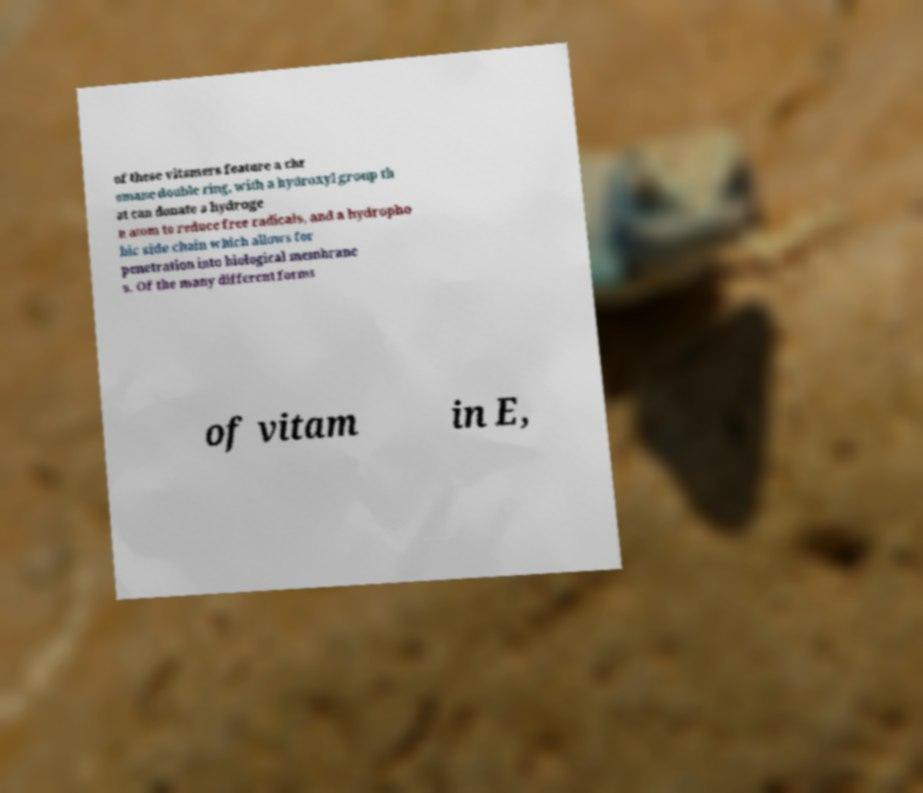What messages or text are displayed in this image? I need them in a readable, typed format. of these vitamers feature a chr omane double ring, with a hydroxyl group th at can donate a hydroge n atom to reduce free radicals, and a hydropho bic side chain which allows for penetration into biological membrane s. Of the many different forms of vitam in E, 